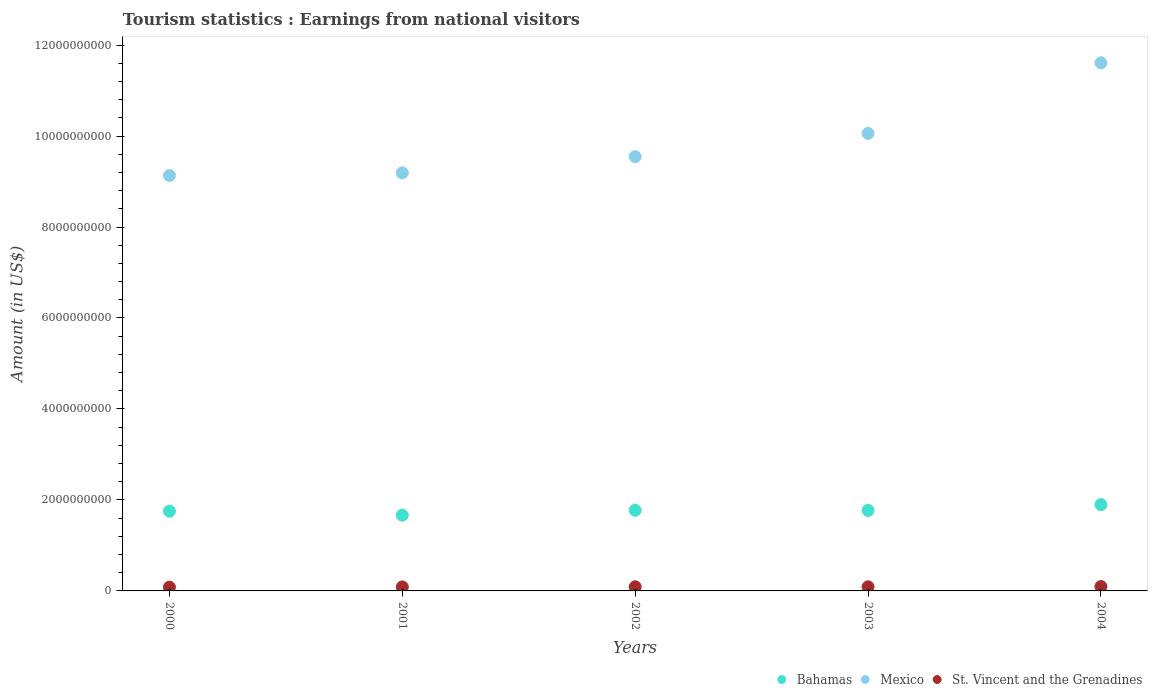What is the earnings from national visitors in St. Vincent and the Grenadines in 2002?
Your response must be concise. 9.10e+07. Across all years, what is the maximum earnings from national visitors in Mexico?
Keep it short and to the point. 1.16e+1. Across all years, what is the minimum earnings from national visitors in Mexico?
Give a very brief answer. 9.13e+09. In which year was the earnings from national visitors in St. Vincent and the Grenadines maximum?
Provide a short and direct response. 2004. In which year was the earnings from national visitors in Mexico minimum?
Your answer should be compact. 2000. What is the total earnings from national visitors in Bahamas in the graph?
Ensure brevity in your answer.  8.86e+09. What is the difference between the earnings from national visitors in St. Vincent and the Grenadines in 2001 and that in 2004?
Offer a very short reply. -7.00e+06. What is the difference between the earnings from national visitors in St. Vincent and the Grenadines in 2004 and the earnings from national visitors in Bahamas in 2001?
Your answer should be very brief. -1.57e+09. What is the average earnings from national visitors in St. Vincent and the Grenadines per year?
Ensure brevity in your answer.  8.98e+07. In the year 2004, what is the difference between the earnings from national visitors in Bahamas and earnings from national visitors in Mexico?
Offer a very short reply. -9.71e+09. In how many years, is the earnings from national visitors in St. Vincent and the Grenadines greater than 7200000000 US$?
Your response must be concise. 0. What is the ratio of the earnings from national visitors in Mexico in 2002 to that in 2003?
Keep it short and to the point. 0.95. What is the difference between the highest and the second highest earnings from national visitors in Bahamas?
Your answer should be compact. 1.24e+08. What is the difference between the highest and the lowest earnings from national visitors in Mexico?
Give a very brief answer. 2.48e+09. Is it the case that in every year, the sum of the earnings from national visitors in Bahamas and earnings from national visitors in Mexico  is greater than the earnings from national visitors in St. Vincent and the Grenadines?
Give a very brief answer. Yes. Is the earnings from national visitors in Mexico strictly greater than the earnings from national visitors in Bahamas over the years?
Provide a succinct answer. Yes. Is the earnings from national visitors in St. Vincent and the Grenadines strictly less than the earnings from national visitors in Bahamas over the years?
Offer a very short reply. Yes. How many years are there in the graph?
Provide a short and direct response. 5. What is the difference between two consecutive major ticks on the Y-axis?
Your answer should be compact. 2.00e+09. Are the values on the major ticks of Y-axis written in scientific E-notation?
Offer a very short reply. No. Does the graph contain any zero values?
Your answer should be compact. No. Does the graph contain grids?
Provide a short and direct response. No. What is the title of the graph?
Make the answer very short. Tourism statistics : Earnings from national visitors. Does "Bahamas" appear as one of the legend labels in the graph?
Offer a terse response. Yes. What is the label or title of the X-axis?
Make the answer very short. Years. What is the label or title of the Y-axis?
Offer a very short reply. Amount (in US$). What is the Amount (in US$) in Bahamas in 2000?
Your answer should be very brief. 1.75e+09. What is the Amount (in US$) of Mexico in 2000?
Make the answer very short. 9.13e+09. What is the Amount (in US$) of St. Vincent and the Grenadines in 2000?
Offer a very short reply. 8.20e+07. What is the Amount (in US$) in Bahamas in 2001?
Provide a succinct answer. 1.66e+09. What is the Amount (in US$) of Mexico in 2001?
Provide a succinct answer. 9.19e+09. What is the Amount (in US$) in St. Vincent and the Grenadines in 2001?
Your answer should be very brief. 8.90e+07. What is the Amount (in US$) of Bahamas in 2002?
Ensure brevity in your answer.  1.77e+09. What is the Amount (in US$) of Mexico in 2002?
Keep it short and to the point. 9.55e+09. What is the Amount (in US$) in St. Vincent and the Grenadines in 2002?
Offer a terse response. 9.10e+07. What is the Amount (in US$) of Bahamas in 2003?
Ensure brevity in your answer.  1.77e+09. What is the Amount (in US$) in Mexico in 2003?
Your answer should be very brief. 1.01e+1. What is the Amount (in US$) in St. Vincent and the Grenadines in 2003?
Keep it short and to the point. 9.10e+07. What is the Amount (in US$) of Bahamas in 2004?
Your answer should be compact. 1.90e+09. What is the Amount (in US$) in Mexico in 2004?
Your answer should be very brief. 1.16e+1. What is the Amount (in US$) of St. Vincent and the Grenadines in 2004?
Ensure brevity in your answer.  9.60e+07. Across all years, what is the maximum Amount (in US$) in Bahamas?
Make the answer very short. 1.90e+09. Across all years, what is the maximum Amount (in US$) of Mexico?
Provide a succinct answer. 1.16e+1. Across all years, what is the maximum Amount (in US$) of St. Vincent and the Grenadines?
Offer a very short reply. 9.60e+07. Across all years, what is the minimum Amount (in US$) of Bahamas?
Ensure brevity in your answer.  1.66e+09. Across all years, what is the minimum Amount (in US$) of Mexico?
Provide a short and direct response. 9.13e+09. Across all years, what is the minimum Amount (in US$) of St. Vincent and the Grenadines?
Your answer should be very brief. 8.20e+07. What is the total Amount (in US$) in Bahamas in the graph?
Keep it short and to the point. 8.86e+09. What is the total Amount (in US$) of Mexico in the graph?
Your answer should be very brief. 4.95e+1. What is the total Amount (in US$) of St. Vincent and the Grenadines in the graph?
Ensure brevity in your answer.  4.49e+08. What is the difference between the Amount (in US$) of Bahamas in 2000 and that in 2001?
Your response must be concise. 8.80e+07. What is the difference between the Amount (in US$) in Mexico in 2000 and that in 2001?
Keep it short and to the point. -5.70e+07. What is the difference between the Amount (in US$) in St. Vincent and the Grenadines in 2000 and that in 2001?
Make the answer very short. -7.00e+06. What is the difference between the Amount (in US$) in Bahamas in 2000 and that in 2002?
Give a very brief answer. -2.00e+07. What is the difference between the Amount (in US$) of Mexico in 2000 and that in 2002?
Keep it short and to the point. -4.14e+08. What is the difference between the Amount (in US$) of St. Vincent and the Grenadines in 2000 and that in 2002?
Provide a short and direct response. -9.00e+06. What is the difference between the Amount (in US$) of Bahamas in 2000 and that in 2003?
Your response must be concise. -1.70e+07. What is the difference between the Amount (in US$) of Mexico in 2000 and that in 2003?
Your answer should be very brief. -9.25e+08. What is the difference between the Amount (in US$) of St. Vincent and the Grenadines in 2000 and that in 2003?
Keep it short and to the point. -9.00e+06. What is the difference between the Amount (in US$) of Bahamas in 2000 and that in 2004?
Keep it short and to the point. -1.44e+08. What is the difference between the Amount (in US$) of Mexico in 2000 and that in 2004?
Your answer should be compact. -2.48e+09. What is the difference between the Amount (in US$) of St. Vincent and the Grenadines in 2000 and that in 2004?
Keep it short and to the point. -1.40e+07. What is the difference between the Amount (in US$) in Bahamas in 2001 and that in 2002?
Offer a terse response. -1.08e+08. What is the difference between the Amount (in US$) of Mexico in 2001 and that in 2002?
Your answer should be very brief. -3.57e+08. What is the difference between the Amount (in US$) of St. Vincent and the Grenadines in 2001 and that in 2002?
Your answer should be compact. -2.00e+06. What is the difference between the Amount (in US$) in Bahamas in 2001 and that in 2003?
Your response must be concise. -1.05e+08. What is the difference between the Amount (in US$) of Mexico in 2001 and that in 2003?
Ensure brevity in your answer.  -8.68e+08. What is the difference between the Amount (in US$) in St. Vincent and the Grenadines in 2001 and that in 2003?
Provide a succinct answer. -2.00e+06. What is the difference between the Amount (in US$) in Bahamas in 2001 and that in 2004?
Offer a very short reply. -2.32e+08. What is the difference between the Amount (in US$) of Mexico in 2001 and that in 2004?
Your answer should be compact. -2.42e+09. What is the difference between the Amount (in US$) in St. Vincent and the Grenadines in 2001 and that in 2004?
Your answer should be very brief. -7.00e+06. What is the difference between the Amount (in US$) in Bahamas in 2002 and that in 2003?
Your answer should be very brief. 3.00e+06. What is the difference between the Amount (in US$) of Mexico in 2002 and that in 2003?
Offer a terse response. -5.11e+08. What is the difference between the Amount (in US$) of St. Vincent and the Grenadines in 2002 and that in 2003?
Offer a very short reply. 0. What is the difference between the Amount (in US$) of Bahamas in 2002 and that in 2004?
Give a very brief answer. -1.24e+08. What is the difference between the Amount (in US$) of Mexico in 2002 and that in 2004?
Make the answer very short. -2.06e+09. What is the difference between the Amount (in US$) of St. Vincent and the Grenadines in 2002 and that in 2004?
Provide a short and direct response. -5.00e+06. What is the difference between the Amount (in US$) in Bahamas in 2003 and that in 2004?
Make the answer very short. -1.27e+08. What is the difference between the Amount (in US$) of Mexico in 2003 and that in 2004?
Your response must be concise. -1.55e+09. What is the difference between the Amount (in US$) of St. Vincent and the Grenadines in 2003 and that in 2004?
Your response must be concise. -5.00e+06. What is the difference between the Amount (in US$) of Bahamas in 2000 and the Amount (in US$) of Mexico in 2001?
Your answer should be very brief. -7.44e+09. What is the difference between the Amount (in US$) of Bahamas in 2000 and the Amount (in US$) of St. Vincent and the Grenadines in 2001?
Offer a terse response. 1.66e+09. What is the difference between the Amount (in US$) in Mexico in 2000 and the Amount (in US$) in St. Vincent and the Grenadines in 2001?
Give a very brief answer. 9.04e+09. What is the difference between the Amount (in US$) in Bahamas in 2000 and the Amount (in US$) in Mexico in 2002?
Ensure brevity in your answer.  -7.79e+09. What is the difference between the Amount (in US$) of Bahamas in 2000 and the Amount (in US$) of St. Vincent and the Grenadines in 2002?
Your answer should be very brief. 1.66e+09. What is the difference between the Amount (in US$) of Mexico in 2000 and the Amount (in US$) of St. Vincent and the Grenadines in 2002?
Keep it short and to the point. 9.04e+09. What is the difference between the Amount (in US$) in Bahamas in 2000 and the Amount (in US$) in Mexico in 2003?
Keep it short and to the point. -8.30e+09. What is the difference between the Amount (in US$) of Bahamas in 2000 and the Amount (in US$) of St. Vincent and the Grenadines in 2003?
Provide a succinct answer. 1.66e+09. What is the difference between the Amount (in US$) in Mexico in 2000 and the Amount (in US$) in St. Vincent and the Grenadines in 2003?
Provide a short and direct response. 9.04e+09. What is the difference between the Amount (in US$) of Bahamas in 2000 and the Amount (in US$) of Mexico in 2004?
Your answer should be compact. -9.86e+09. What is the difference between the Amount (in US$) of Bahamas in 2000 and the Amount (in US$) of St. Vincent and the Grenadines in 2004?
Your answer should be compact. 1.66e+09. What is the difference between the Amount (in US$) of Mexico in 2000 and the Amount (in US$) of St. Vincent and the Grenadines in 2004?
Your answer should be compact. 9.04e+09. What is the difference between the Amount (in US$) of Bahamas in 2001 and the Amount (in US$) of Mexico in 2002?
Offer a very short reply. -7.88e+09. What is the difference between the Amount (in US$) of Bahamas in 2001 and the Amount (in US$) of St. Vincent and the Grenadines in 2002?
Make the answer very short. 1.57e+09. What is the difference between the Amount (in US$) in Mexico in 2001 and the Amount (in US$) in St. Vincent and the Grenadines in 2002?
Give a very brief answer. 9.10e+09. What is the difference between the Amount (in US$) of Bahamas in 2001 and the Amount (in US$) of Mexico in 2003?
Keep it short and to the point. -8.39e+09. What is the difference between the Amount (in US$) in Bahamas in 2001 and the Amount (in US$) in St. Vincent and the Grenadines in 2003?
Keep it short and to the point. 1.57e+09. What is the difference between the Amount (in US$) of Mexico in 2001 and the Amount (in US$) of St. Vincent and the Grenadines in 2003?
Keep it short and to the point. 9.10e+09. What is the difference between the Amount (in US$) of Bahamas in 2001 and the Amount (in US$) of Mexico in 2004?
Ensure brevity in your answer.  -9.94e+09. What is the difference between the Amount (in US$) of Bahamas in 2001 and the Amount (in US$) of St. Vincent and the Grenadines in 2004?
Your response must be concise. 1.57e+09. What is the difference between the Amount (in US$) in Mexico in 2001 and the Amount (in US$) in St. Vincent and the Grenadines in 2004?
Provide a short and direct response. 9.09e+09. What is the difference between the Amount (in US$) of Bahamas in 2002 and the Amount (in US$) of Mexico in 2003?
Offer a terse response. -8.28e+09. What is the difference between the Amount (in US$) in Bahamas in 2002 and the Amount (in US$) in St. Vincent and the Grenadines in 2003?
Your answer should be compact. 1.68e+09. What is the difference between the Amount (in US$) of Mexico in 2002 and the Amount (in US$) of St. Vincent and the Grenadines in 2003?
Give a very brief answer. 9.46e+09. What is the difference between the Amount (in US$) of Bahamas in 2002 and the Amount (in US$) of Mexico in 2004?
Provide a short and direct response. -9.84e+09. What is the difference between the Amount (in US$) of Bahamas in 2002 and the Amount (in US$) of St. Vincent and the Grenadines in 2004?
Your response must be concise. 1.68e+09. What is the difference between the Amount (in US$) of Mexico in 2002 and the Amount (in US$) of St. Vincent and the Grenadines in 2004?
Make the answer very short. 9.45e+09. What is the difference between the Amount (in US$) of Bahamas in 2003 and the Amount (in US$) of Mexico in 2004?
Offer a very short reply. -9.84e+09. What is the difference between the Amount (in US$) of Bahamas in 2003 and the Amount (in US$) of St. Vincent and the Grenadines in 2004?
Your answer should be compact. 1.67e+09. What is the difference between the Amount (in US$) in Mexico in 2003 and the Amount (in US$) in St. Vincent and the Grenadines in 2004?
Offer a terse response. 9.96e+09. What is the average Amount (in US$) in Bahamas per year?
Your answer should be compact. 1.77e+09. What is the average Amount (in US$) of Mexico per year?
Your answer should be very brief. 9.91e+09. What is the average Amount (in US$) of St. Vincent and the Grenadines per year?
Give a very brief answer. 8.98e+07. In the year 2000, what is the difference between the Amount (in US$) in Bahamas and Amount (in US$) in Mexico?
Give a very brief answer. -7.38e+09. In the year 2000, what is the difference between the Amount (in US$) in Bahamas and Amount (in US$) in St. Vincent and the Grenadines?
Your answer should be compact. 1.67e+09. In the year 2000, what is the difference between the Amount (in US$) of Mexico and Amount (in US$) of St. Vincent and the Grenadines?
Ensure brevity in your answer.  9.05e+09. In the year 2001, what is the difference between the Amount (in US$) of Bahamas and Amount (in US$) of Mexico?
Your answer should be compact. -7.52e+09. In the year 2001, what is the difference between the Amount (in US$) of Bahamas and Amount (in US$) of St. Vincent and the Grenadines?
Your answer should be compact. 1.58e+09. In the year 2001, what is the difference between the Amount (in US$) in Mexico and Amount (in US$) in St. Vincent and the Grenadines?
Offer a terse response. 9.10e+09. In the year 2002, what is the difference between the Amount (in US$) in Bahamas and Amount (in US$) in Mexico?
Make the answer very short. -7.77e+09. In the year 2002, what is the difference between the Amount (in US$) of Bahamas and Amount (in US$) of St. Vincent and the Grenadines?
Give a very brief answer. 1.68e+09. In the year 2002, what is the difference between the Amount (in US$) in Mexico and Amount (in US$) in St. Vincent and the Grenadines?
Provide a succinct answer. 9.46e+09. In the year 2003, what is the difference between the Amount (in US$) in Bahamas and Amount (in US$) in Mexico?
Your response must be concise. -8.29e+09. In the year 2003, what is the difference between the Amount (in US$) of Bahamas and Amount (in US$) of St. Vincent and the Grenadines?
Your answer should be very brief. 1.68e+09. In the year 2003, what is the difference between the Amount (in US$) in Mexico and Amount (in US$) in St. Vincent and the Grenadines?
Keep it short and to the point. 9.97e+09. In the year 2004, what is the difference between the Amount (in US$) of Bahamas and Amount (in US$) of Mexico?
Give a very brief answer. -9.71e+09. In the year 2004, what is the difference between the Amount (in US$) in Bahamas and Amount (in US$) in St. Vincent and the Grenadines?
Keep it short and to the point. 1.80e+09. In the year 2004, what is the difference between the Amount (in US$) in Mexico and Amount (in US$) in St. Vincent and the Grenadines?
Make the answer very short. 1.15e+1. What is the ratio of the Amount (in US$) in Bahamas in 2000 to that in 2001?
Offer a terse response. 1.05. What is the ratio of the Amount (in US$) of Mexico in 2000 to that in 2001?
Provide a succinct answer. 0.99. What is the ratio of the Amount (in US$) of St. Vincent and the Grenadines in 2000 to that in 2001?
Keep it short and to the point. 0.92. What is the ratio of the Amount (in US$) in Bahamas in 2000 to that in 2002?
Your answer should be very brief. 0.99. What is the ratio of the Amount (in US$) in Mexico in 2000 to that in 2002?
Provide a short and direct response. 0.96. What is the ratio of the Amount (in US$) in St. Vincent and the Grenadines in 2000 to that in 2002?
Your answer should be compact. 0.9. What is the ratio of the Amount (in US$) of Bahamas in 2000 to that in 2003?
Your answer should be compact. 0.99. What is the ratio of the Amount (in US$) of Mexico in 2000 to that in 2003?
Your response must be concise. 0.91. What is the ratio of the Amount (in US$) in St. Vincent and the Grenadines in 2000 to that in 2003?
Provide a succinct answer. 0.9. What is the ratio of the Amount (in US$) of Bahamas in 2000 to that in 2004?
Offer a very short reply. 0.92. What is the ratio of the Amount (in US$) in Mexico in 2000 to that in 2004?
Your response must be concise. 0.79. What is the ratio of the Amount (in US$) of St. Vincent and the Grenadines in 2000 to that in 2004?
Your answer should be compact. 0.85. What is the ratio of the Amount (in US$) in Bahamas in 2001 to that in 2002?
Your answer should be compact. 0.94. What is the ratio of the Amount (in US$) of Mexico in 2001 to that in 2002?
Offer a very short reply. 0.96. What is the ratio of the Amount (in US$) of St. Vincent and the Grenadines in 2001 to that in 2002?
Your response must be concise. 0.98. What is the ratio of the Amount (in US$) of Bahamas in 2001 to that in 2003?
Provide a succinct answer. 0.94. What is the ratio of the Amount (in US$) of Mexico in 2001 to that in 2003?
Ensure brevity in your answer.  0.91. What is the ratio of the Amount (in US$) of Bahamas in 2001 to that in 2004?
Your answer should be compact. 0.88. What is the ratio of the Amount (in US$) in Mexico in 2001 to that in 2004?
Provide a succinct answer. 0.79. What is the ratio of the Amount (in US$) of St. Vincent and the Grenadines in 2001 to that in 2004?
Your answer should be very brief. 0.93. What is the ratio of the Amount (in US$) of Bahamas in 2002 to that in 2003?
Offer a very short reply. 1. What is the ratio of the Amount (in US$) of Mexico in 2002 to that in 2003?
Keep it short and to the point. 0.95. What is the ratio of the Amount (in US$) of Bahamas in 2002 to that in 2004?
Make the answer very short. 0.93. What is the ratio of the Amount (in US$) in Mexico in 2002 to that in 2004?
Make the answer very short. 0.82. What is the ratio of the Amount (in US$) of St. Vincent and the Grenadines in 2002 to that in 2004?
Provide a succinct answer. 0.95. What is the ratio of the Amount (in US$) of Bahamas in 2003 to that in 2004?
Provide a short and direct response. 0.93. What is the ratio of the Amount (in US$) in Mexico in 2003 to that in 2004?
Your answer should be compact. 0.87. What is the ratio of the Amount (in US$) in St. Vincent and the Grenadines in 2003 to that in 2004?
Provide a succinct answer. 0.95. What is the difference between the highest and the second highest Amount (in US$) of Bahamas?
Your answer should be compact. 1.24e+08. What is the difference between the highest and the second highest Amount (in US$) in Mexico?
Offer a very short reply. 1.55e+09. What is the difference between the highest and the second highest Amount (in US$) in St. Vincent and the Grenadines?
Offer a very short reply. 5.00e+06. What is the difference between the highest and the lowest Amount (in US$) in Bahamas?
Provide a succinct answer. 2.32e+08. What is the difference between the highest and the lowest Amount (in US$) of Mexico?
Keep it short and to the point. 2.48e+09. What is the difference between the highest and the lowest Amount (in US$) of St. Vincent and the Grenadines?
Give a very brief answer. 1.40e+07. 